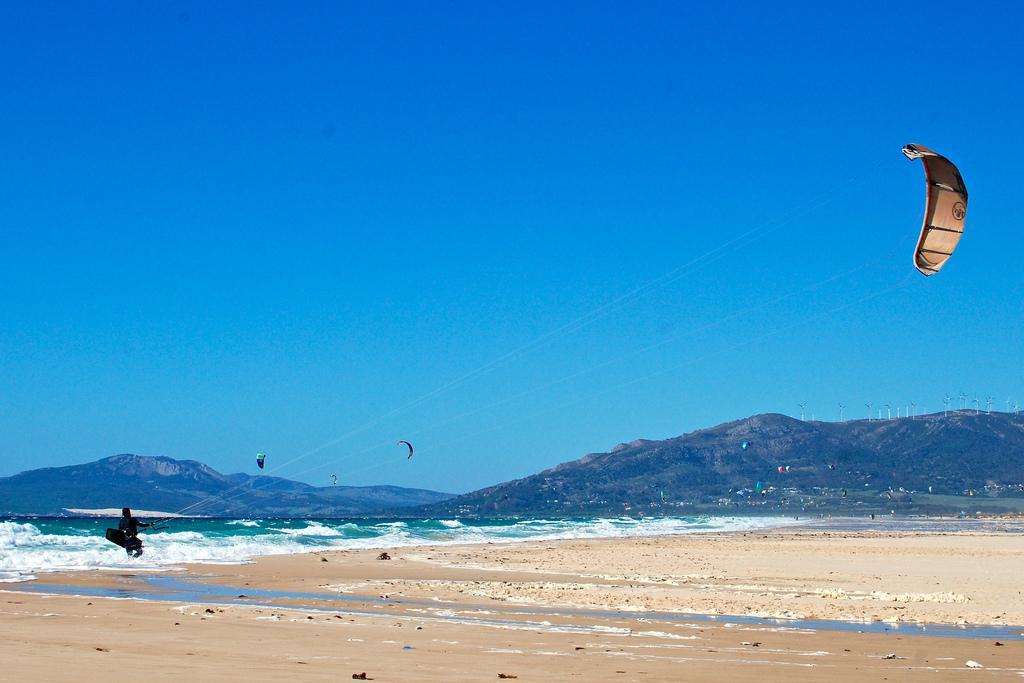Question: what type of weather is it?
Choices:
A. Snowy.
B. Cloudy.
C. Sunny.
D. Rainy.
Answer with the letter. Answer: C Question: how many people are there?
Choices:
A. Three.
B. Four.
C. One.
D. Eight.
Answer with the letter. Answer: C Question: where is the photo taken?
Choices:
A. Beach.
B. At the party.
C. At the Park.
D. In the woods.
Answer with the letter. Answer: A Question: what is the person doing?
Choices:
A. Playing football.
B. Kite surfing.
C. Gardening.
D. Walking the dogs.
Answer with the letter. Answer: B Question: where was the photo taken?
Choices:
A. At the ocean.
B. At the beach.
C. At the river bank.
D. At the town pool.
Answer with the letter. Answer: B Question: who is in the shallows?
Choices:
A. A fly fisher.
B. A woman collecting seashells.
C. A surfer.
D. Toddlers splashing.
Answer with the letter. Answer: C Question: what color are the waves?
Choices:
A. Blue.
B. Green.
C. Mixed.
D. White.
Answer with the letter. Answer: D Question: what is the person in the distance doing?
Choices:
A. Dancing.
B. Climbing.
C. Kite surfing.
D. Snowboarding.
Answer with the letter. Answer: C Question: what color is the sky and water?
Choices:
A. Blue.
B. Grey.
C. Black.
D. Yellow.
Answer with the letter. Answer: A Question: what is the man carrying?
Choices:
A. A bag.
B. A hat.
C. A surfboard.
D. A child.
Answer with the letter. Answer: C Question: what kind of day is it?
Choices:
A. Cloudy.
B. Stormy.
C. Snowy.
D. A sunny day.
Answer with the letter. Answer: D Question: why is it bright out?
Choices:
A. The sun is out.
B. It's day time.
C. The snow is reflecting the sunlight.
D. The clouds have disappeared.
Answer with the letter. Answer: B Question: what bright color is the sky?
Choices:
A. Gray.
B. Red.
C. Blue.
D. Orange.
Answer with the letter. Answer: C Question: how is the view?
Choices:
A. Perfect.
B. Scenic.
C. Vivid.
D. Picturesque.
Answer with the letter. Answer: D Question: what kind of daytime scene is this?
Choices:
A. Bright.
B. Dark.
C. Dim.
D. Light.
Answer with the letter. Answer: A Question: what is in the sky in motion?
Choices:
A. Kite.
B. Airplane.
C. Balloon.
D. Helicopter.
Answer with the letter. Answer: A 